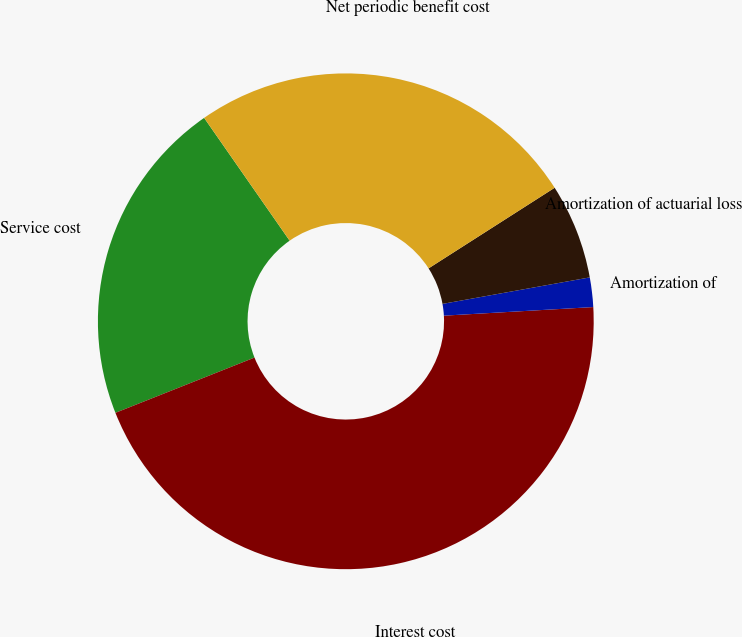<chart> <loc_0><loc_0><loc_500><loc_500><pie_chart><fcel>Service cost<fcel>Interest cost<fcel>Amortization of<fcel>Amortization of actuarial loss<fcel>Net periodic benefit cost<nl><fcel>21.34%<fcel>44.9%<fcel>1.92%<fcel>6.22%<fcel>25.63%<nl></chart> 